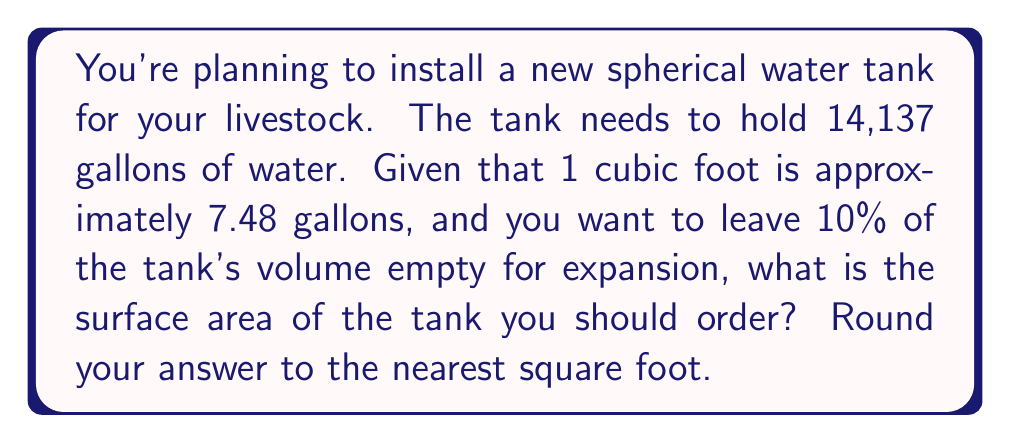Can you answer this question? Let's approach this step-by-step:

1) First, let's convert gallons to cubic feet:
   $$\frac{14,137 \text{ gallons}}{7.48 \text{ gallons/ft}^3} \approx 1,889.97 \text{ ft}^3$$

2) We need to account for the 10% expansion space, so the total volume should be:
   $$1,889.97 \div 0.9 \approx 2,099.97 \text{ ft}^3$$

3) For a sphere, the volume formula is:
   $$V = \frac{4}{3}\pi r^3$$

4) We can solve for the radius:
   $$2,099.97 = \frac{4}{3}\pi r^3$$
   $$r^3 = \frac{2,099.97 \cdot 3}{4\pi} \approx 501.59$$
   $$r \approx \sqrt[3]{501.59} \approx 7.94 \text{ ft}$$

5) Now that we have the radius, we can calculate the surface area using the formula:
   $$A = 4\pi r^2$$

6) Plugging in our radius:
   $$A = 4\pi (7.94)^2 \approx 791.69 \text{ ft}^2$$

7) Rounding to the nearest square foot:
   $$A \approx 792 \text{ ft}^2$$
Answer: 792 ft² 